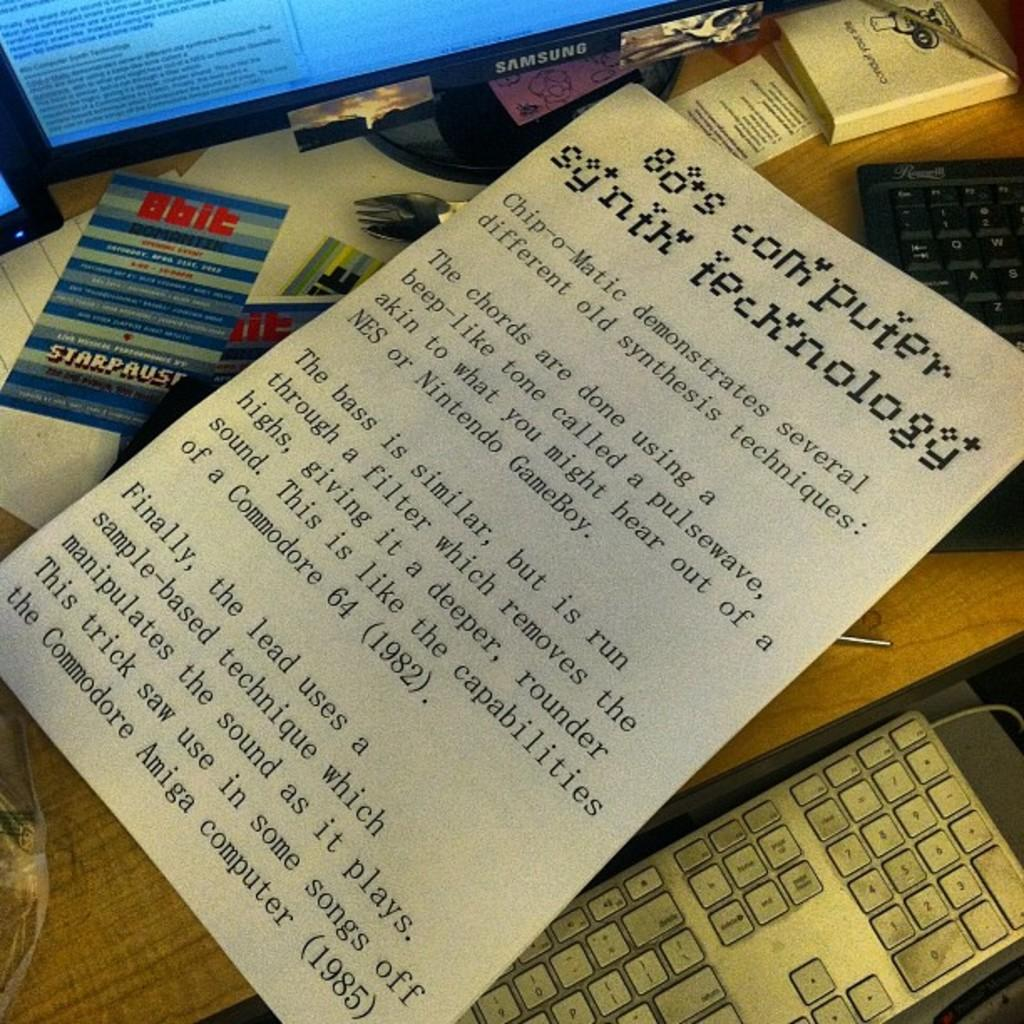What is the primary piece of furniture in the image? There is a table in the image. What is placed on the table? There is a paper with text, keyboards, papers, and books on the table. What type of device is present in the image? There is a system with a screen in the image. How many unspecified objects are in the image? There are a few unspecified objects in the image. What type of cloth is being used for payment in the image? There is no cloth or payment being depicted in the image. 